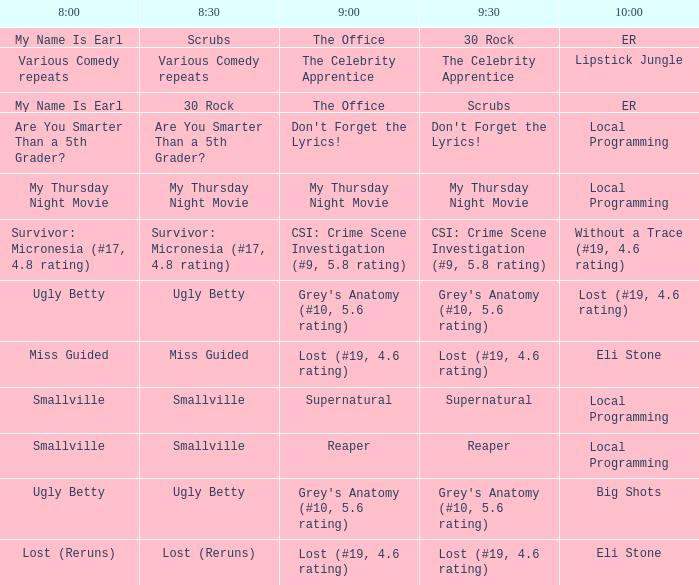What is at 9:00 when at 10:00 it is local programming and at 9:30 it is my thursday night movie? My Thursday Night Movie. 